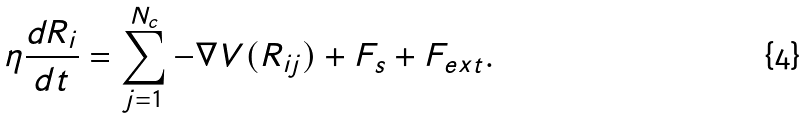Convert formula to latex. <formula><loc_0><loc_0><loc_500><loc_500>\eta \frac { d { R } _ { i } } { d t } = \sum ^ { N _ { c } } _ { j = 1 } - \nabla V ( R _ { i j } ) + { F } _ { s } + { F } _ { e x t } .</formula> 